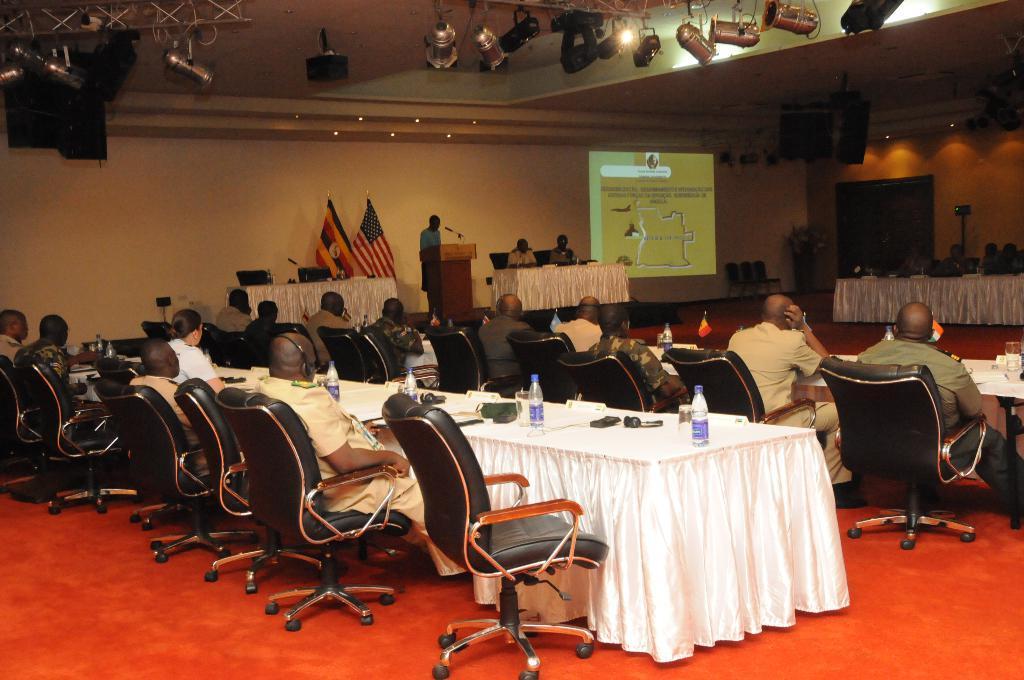Can you describe this image briefly? In the image we can see there are people who are sitting on chair and there is a man who is standing in front of a podium. 